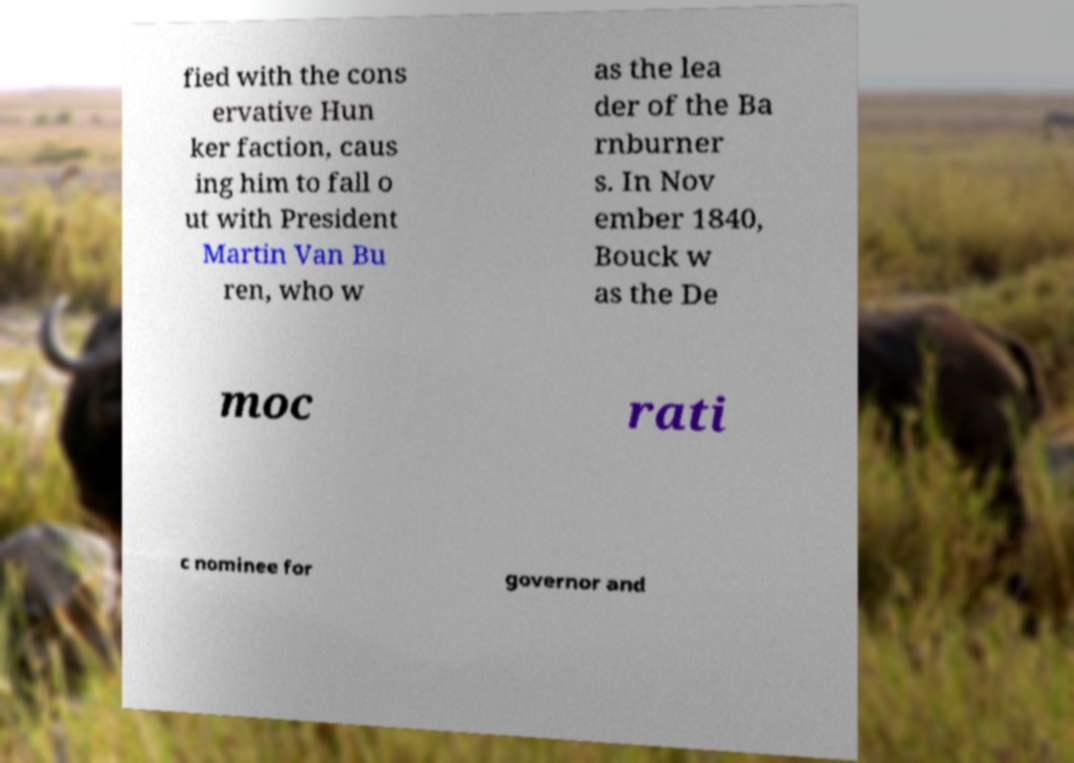Can you accurately transcribe the text from the provided image for me? fied with the cons ervative Hun ker faction, caus ing him to fall o ut with President Martin Van Bu ren, who w as the lea der of the Ba rnburner s. In Nov ember 1840, Bouck w as the De moc rati c nominee for governor and 